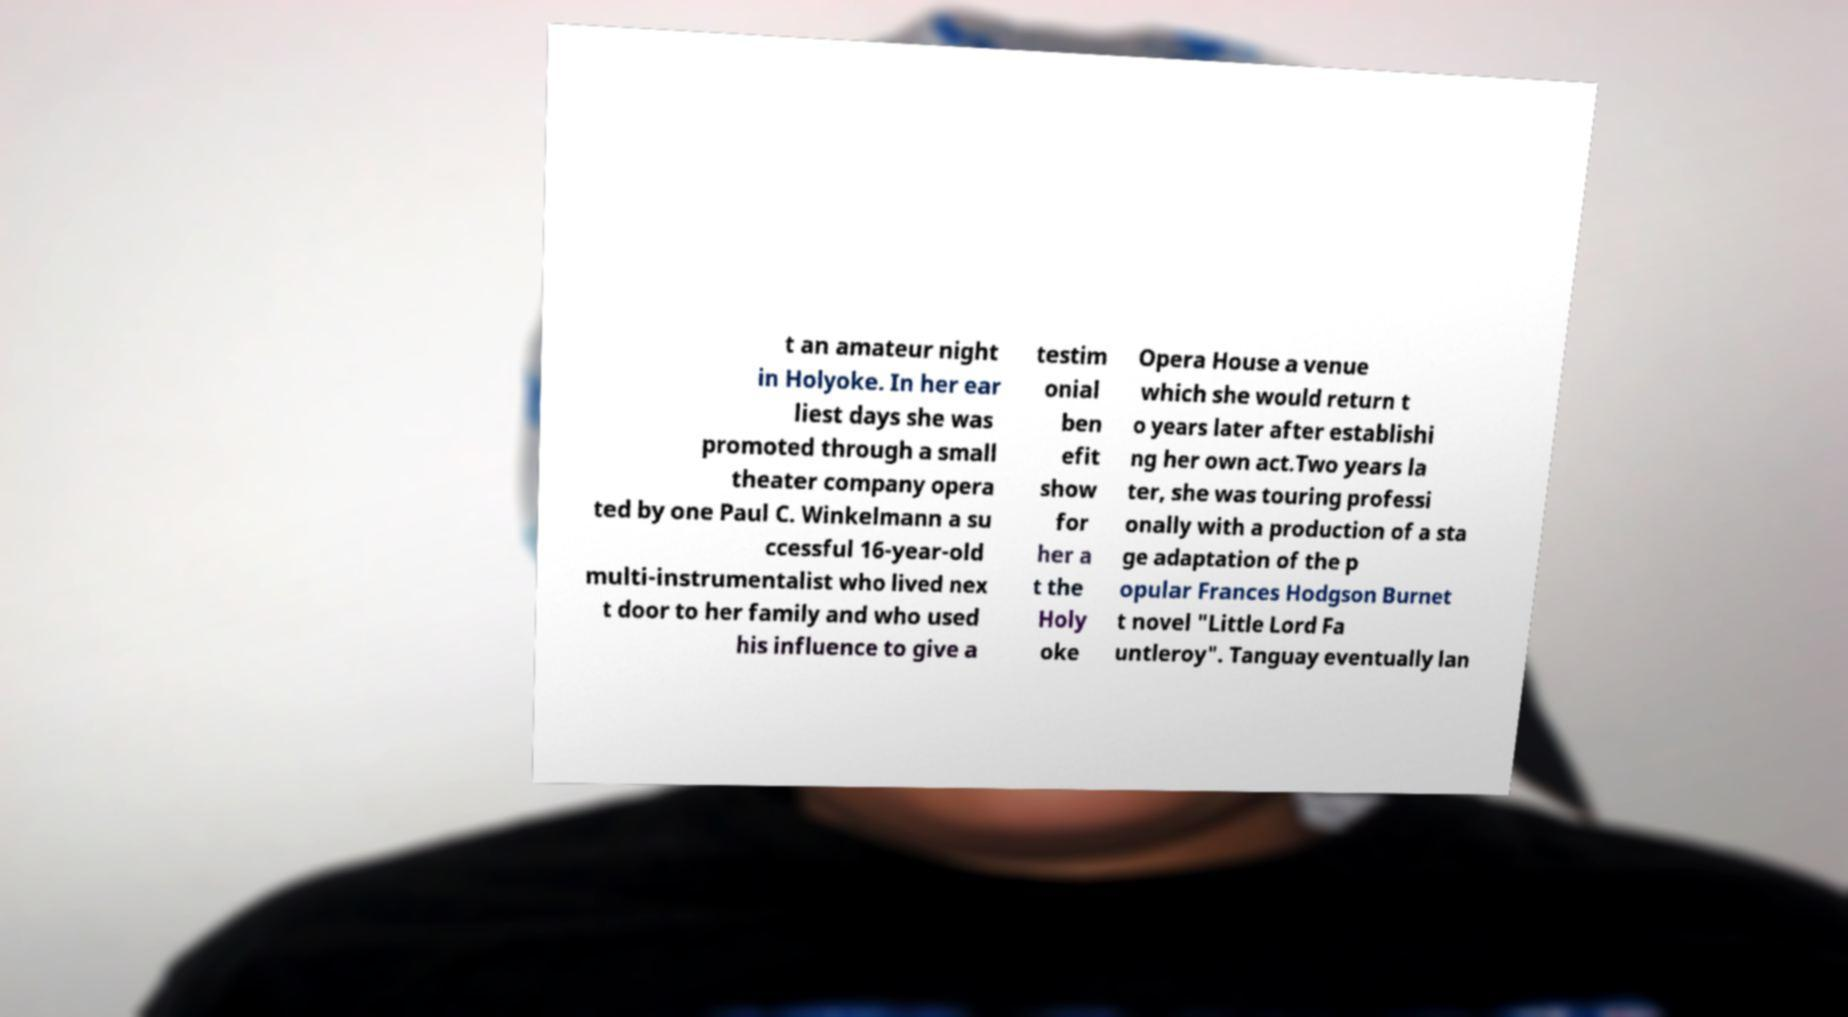Please identify and transcribe the text found in this image. t an amateur night in Holyoke. In her ear liest days she was promoted through a small theater company opera ted by one Paul C. Winkelmann a su ccessful 16-year-old multi-instrumentalist who lived nex t door to her family and who used his influence to give a testim onial ben efit show for her a t the Holy oke Opera House a venue which she would return t o years later after establishi ng her own act.Two years la ter, she was touring professi onally with a production of a sta ge adaptation of the p opular Frances Hodgson Burnet t novel "Little Lord Fa untleroy". Tanguay eventually lan 